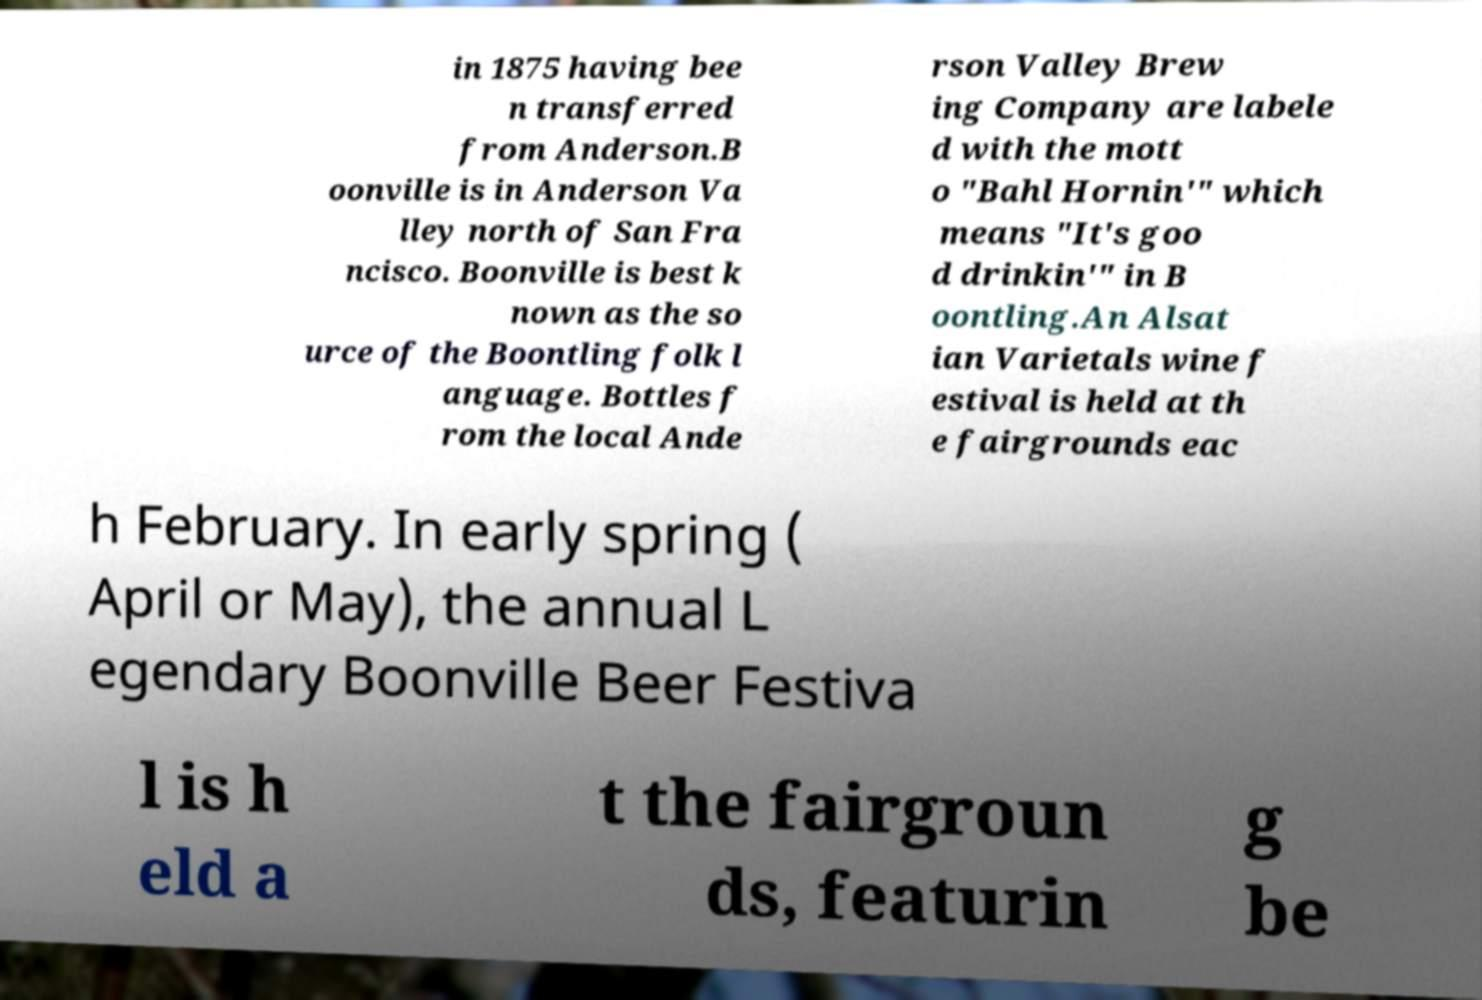I need the written content from this picture converted into text. Can you do that? in 1875 having bee n transferred from Anderson.B oonville is in Anderson Va lley north of San Fra ncisco. Boonville is best k nown as the so urce of the Boontling folk l anguage. Bottles f rom the local Ande rson Valley Brew ing Company are labele d with the mott o "Bahl Hornin'" which means "It's goo d drinkin'" in B oontling.An Alsat ian Varietals wine f estival is held at th e fairgrounds eac h February. In early spring ( April or May), the annual L egendary Boonville Beer Festiva l is h eld a t the fairgroun ds, featurin g be 